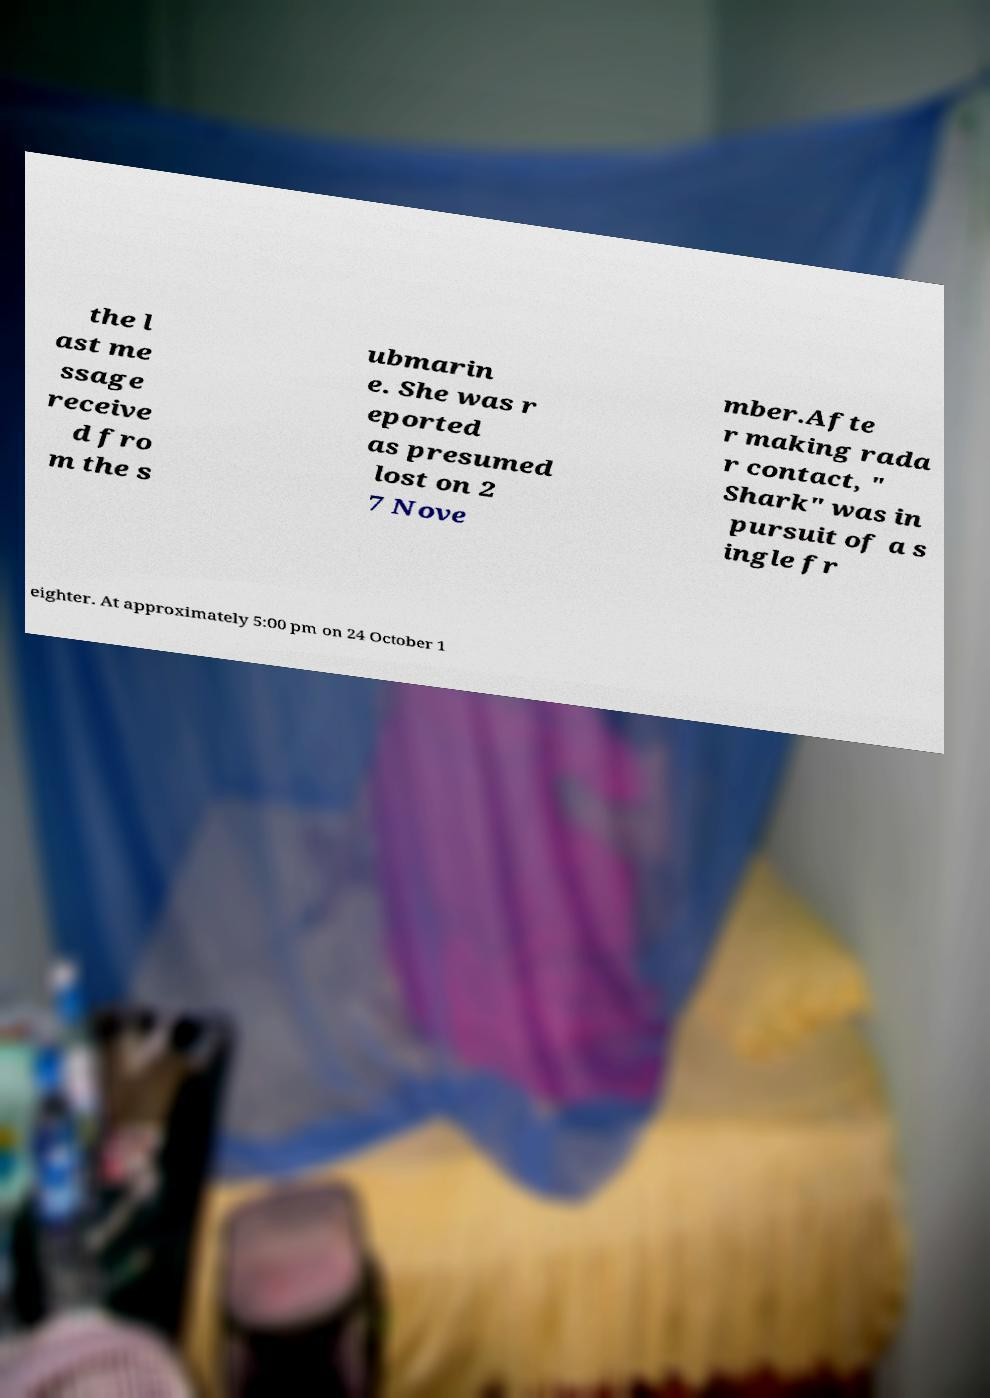Could you extract and type out the text from this image? the l ast me ssage receive d fro m the s ubmarin e. She was r eported as presumed lost on 2 7 Nove mber.Afte r making rada r contact, " Shark" was in pursuit of a s ingle fr eighter. At approximately 5:00 pm on 24 October 1 